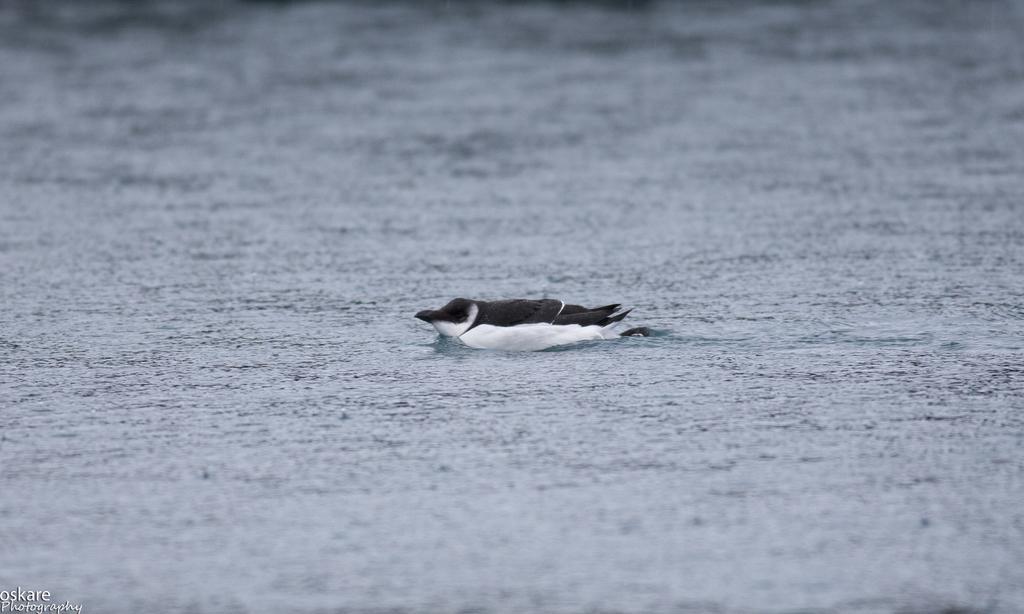How would you summarize this image in a sentence or two? In this picture there is a black and white color duck in the river water. On the bottom left side there is a small quote on it. 